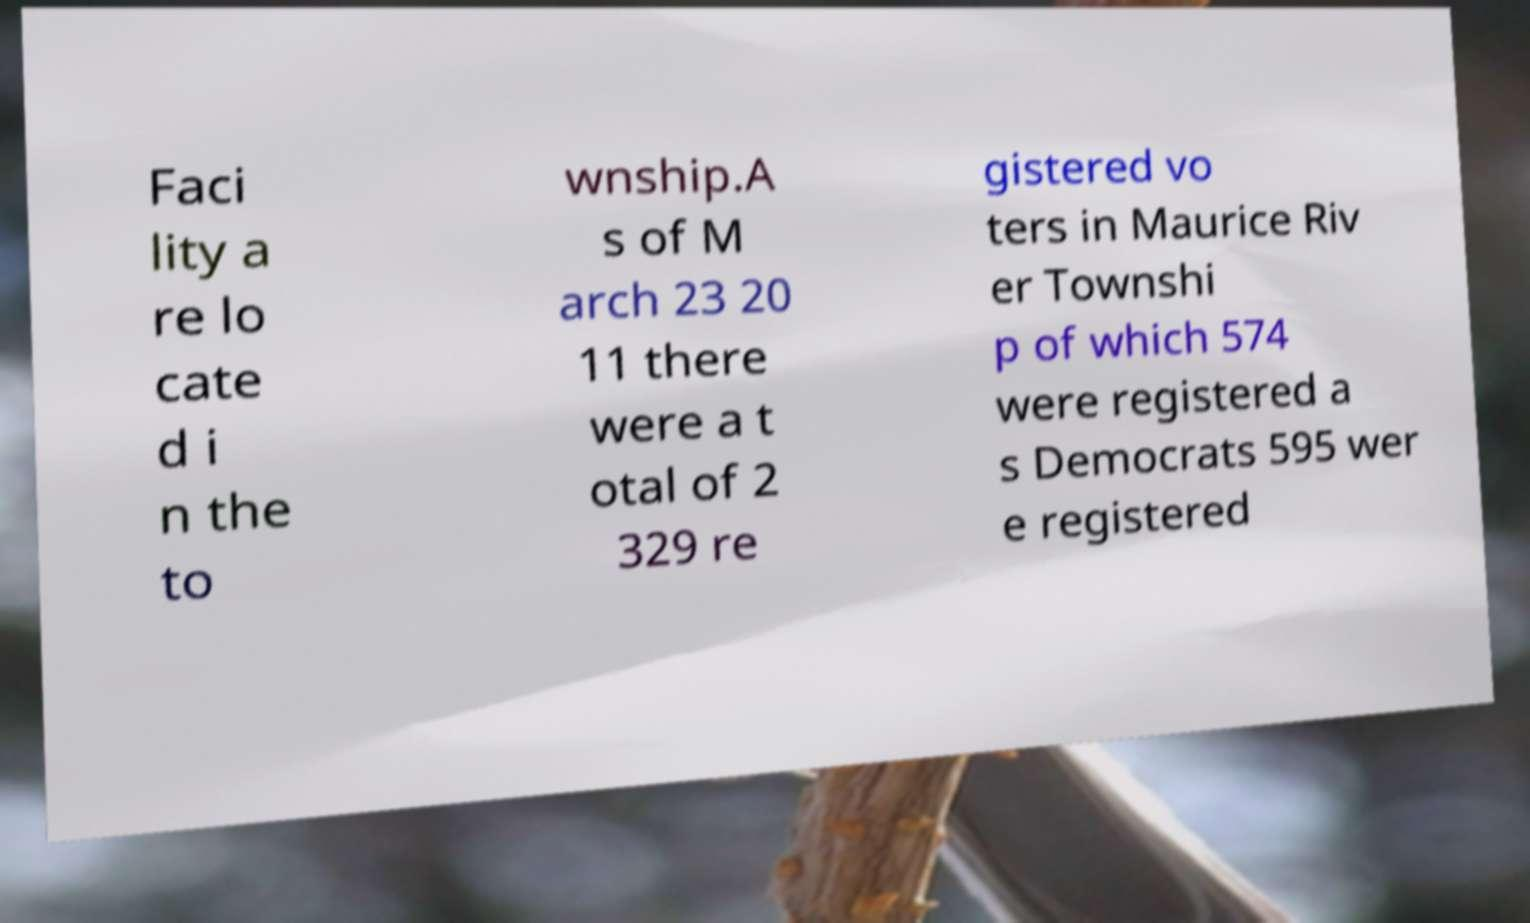Can you read and provide the text displayed in the image?This photo seems to have some interesting text. Can you extract and type it out for me? Faci lity a re lo cate d i n the to wnship.A s of M arch 23 20 11 there were a t otal of 2 329 re gistered vo ters in Maurice Riv er Townshi p of which 574 were registered a s Democrats 595 wer e registered 